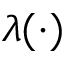<formula> <loc_0><loc_0><loc_500><loc_500>\lambda ( \cdot )</formula> 